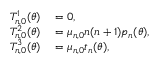Convert formula to latex. <formula><loc_0><loc_0><loc_500><loc_500>\begin{array} { r l } { T _ { n , 0 } ^ { 1 } ( \theta ) } & = 0 , } \\ { T _ { n , 0 } ^ { 2 } ( \theta ) } & = \mu _ { n , 0 } n ( n + 1 ) p _ { n } ( \theta ) , } \\ { T _ { n , 0 } ^ { 3 } ( \theta ) } & = \mu _ { n , 0 } t _ { n } ( \theta ) , } \end{array}</formula> 